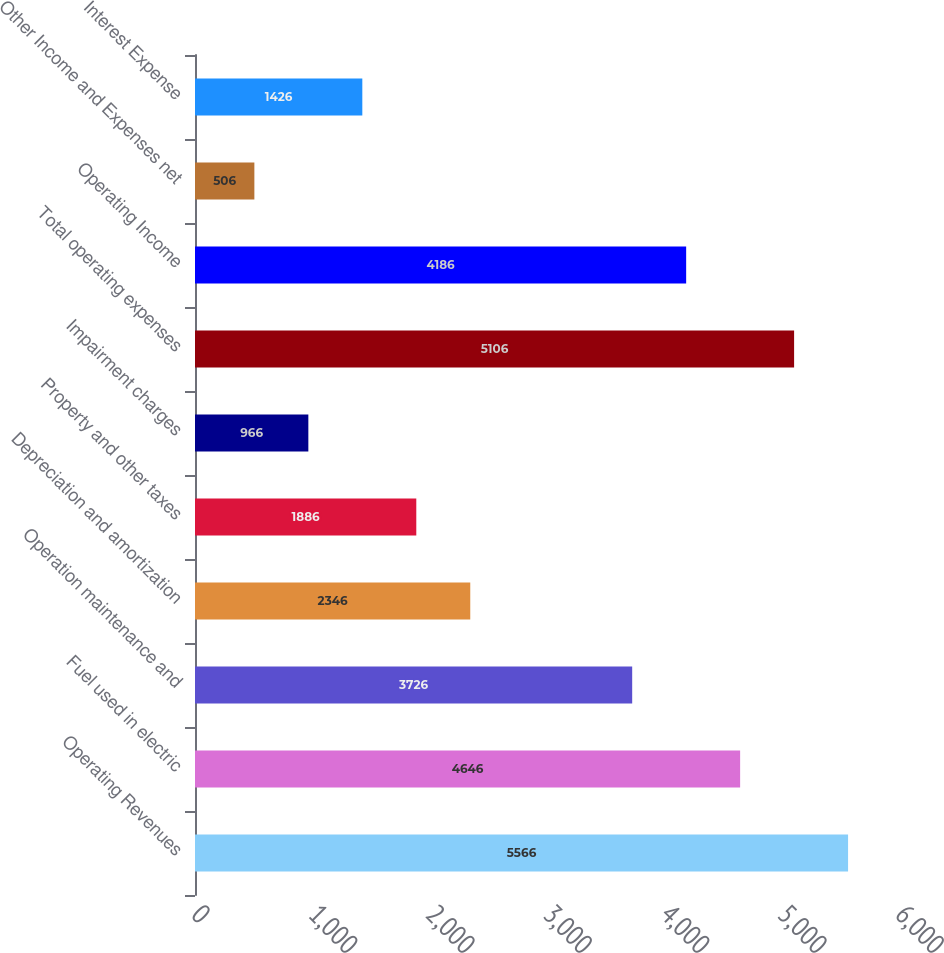Convert chart. <chart><loc_0><loc_0><loc_500><loc_500><bar_chart><fcel>Operating Revenues<fcel>Fuel used in electric<fcel>Operation maintenance and<fcel>Depreciation and amortization<fcel>Property and other taxes<fcel>Impairment charges<fcel>Total operating expenses<fcel>Operating Income<fcel>Other Income and Expenses net<fcel>Interest Expense<nl><fcel>5566<fcel>4646<fcel>3726<fcel>2346<fcel>1886<fcel>966<fcel>5106<fcel>4186<fcel>506<fcel>1426<nl></chart> 